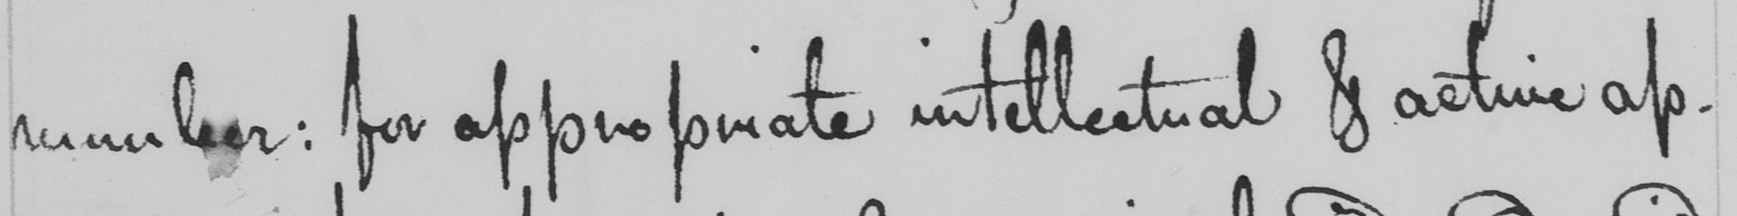What does this handwritten line say? number :  for appropriate intellectual & active ap- 